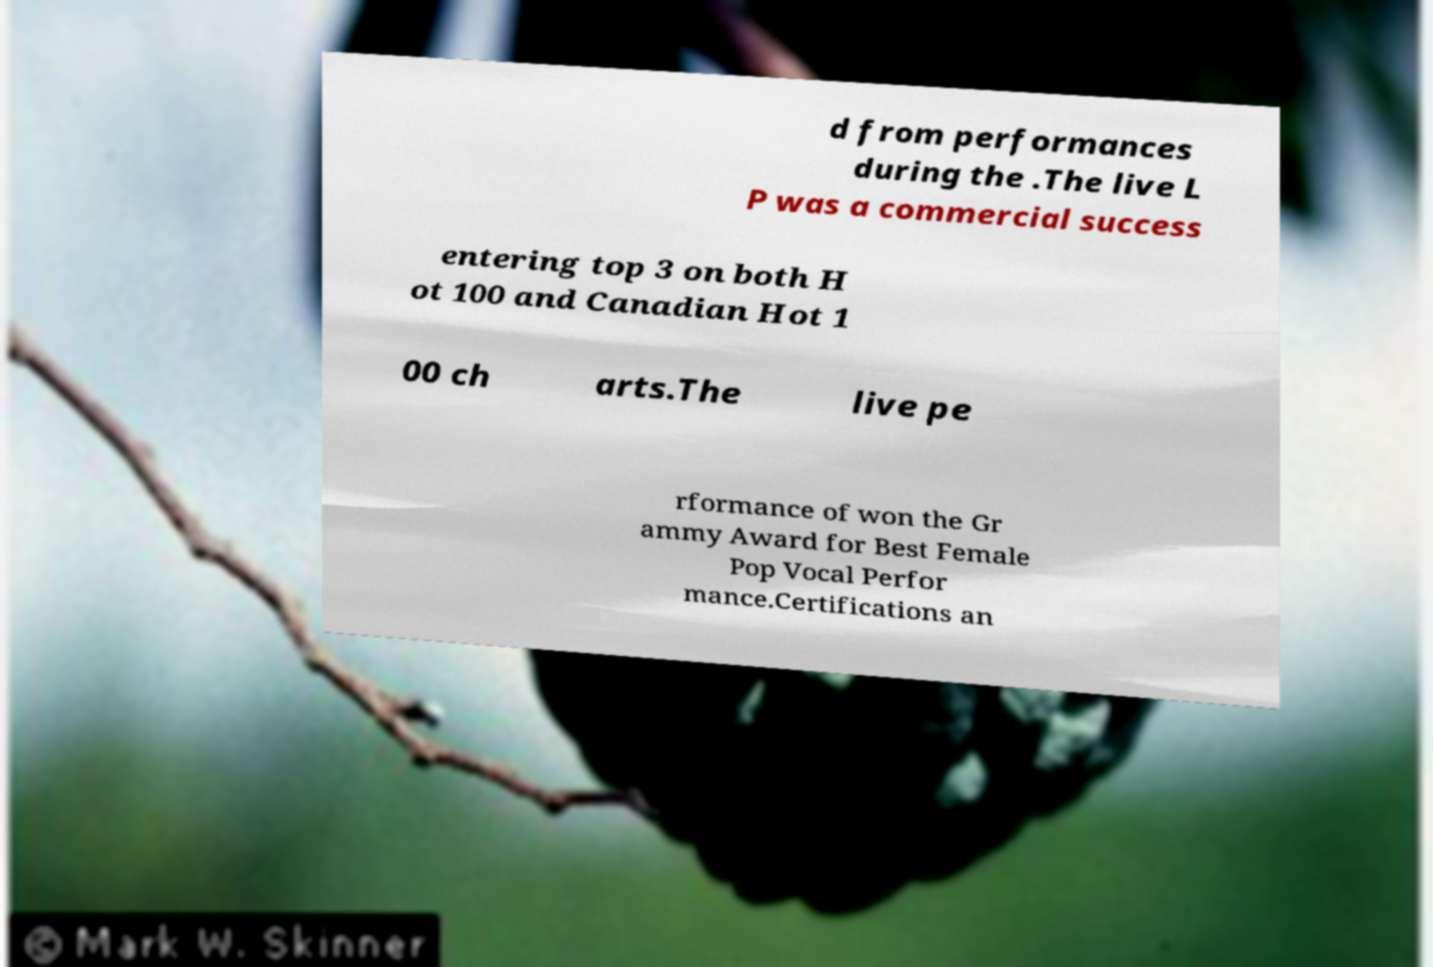There's text embedded in this image that I need extracted. Can you transcribe it verbatim? d from performances during the .The live L P was a commercial success entering top 3 on both H ot 100 and Canadian Hot 1 00 ch arts.The live pe rformance of won the Gr ammy Award for Best Female Pop Vocal Perfor mance.Certifications an 